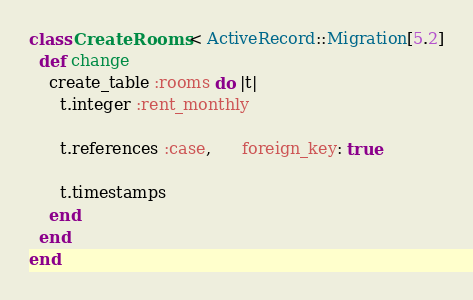<code> <loc_0><loc_0><loc_500><loc_500><_Ruby_>class CreateRooms < ActiveRecord::Migration[5.2]
  def change
    create_table :rooms do |t|
      t.integer :rent_monthly
      
      t.references :case,      foreign_key: true

      t.timestamps
    end
  end
end
</code> 